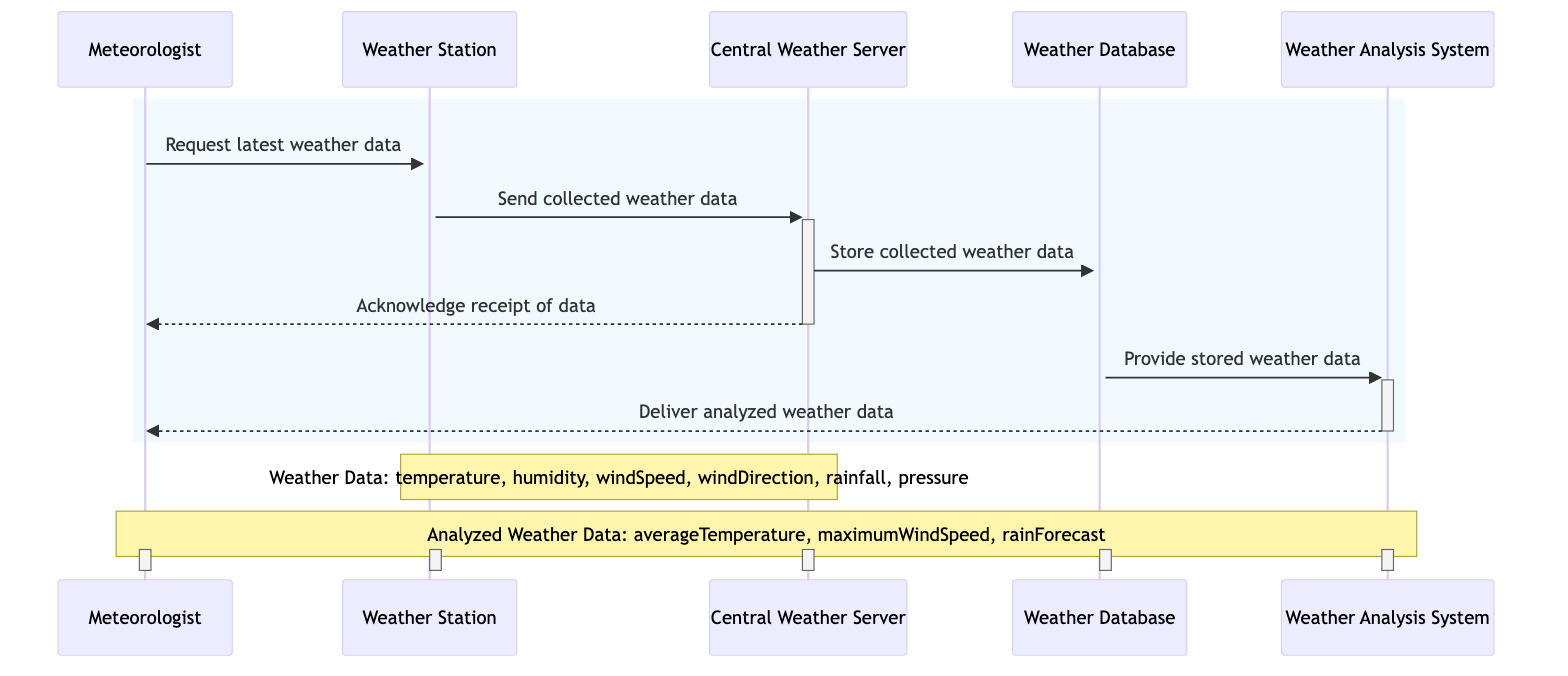What is the first action taken in the diagram? The first action is a request made by the Meteorologist to the Weather Station for the latest weather data. This is indicated by the arrow from 'Meteorologist' to 'Weather Station' labeled 'Request latest weather data'.
Answer: Request latest weather data How many actors are involved in the sequence diagram? There are five actors involved: Meteorologist, Weather Station, Central Weather Server, Weather Database, and Weather Analysis System. This is derived from the list of participants in the diagram.
Answer: Five What is sent from the Weather Station to the Central Weather Server? The Weather Station sends the collected weather data to the Central Weather Server, as shown by the arrow labeled 'Send collected weather data'.
Answer: Collected weather data Which actor receives an acknowledgment after sending data? The Meteorologist receives an acknowledgment after the Central Weather Server sends a message back to them indicating receipt of data. The acknowledgment is specified in the arrow labeled 'Acknowledge receipt of data'.
Answer: Meteorologist What type of data is provided by the Weather Database to the Weather Analysis System? The Weather Database provides stored weather data to the Weather Analysis System, as indicated by the corresponding arrow.
Answer: Stored weather data What are the attributes of the 'Weather Data' data object? The attributes of the Weather Data include temperature, humidity, wind speed, wind direction, rainfall, and pressure. This is mentioned in the note over the Weather Station and Central Weather Server.
Answer: Temperature, humidity, wind speed, wind direction, rainfall, pressure How many messages are exchanged before the analyzed weather data is delivered? There are five messages exchanged in total before the analyzed weather data is delivered to the Meteorologist, including requests, data transfers, and acknowledgments as per the flow.
Answer: Five What does the Weather Analysis System deliver to the Meteorologist? The Weather Analysis System delivers analyzed weather data to the Meteorologist. This is shown by the arrow labeled 'Deliver analyzed weather data'.
Answer: Analyzed weather data 